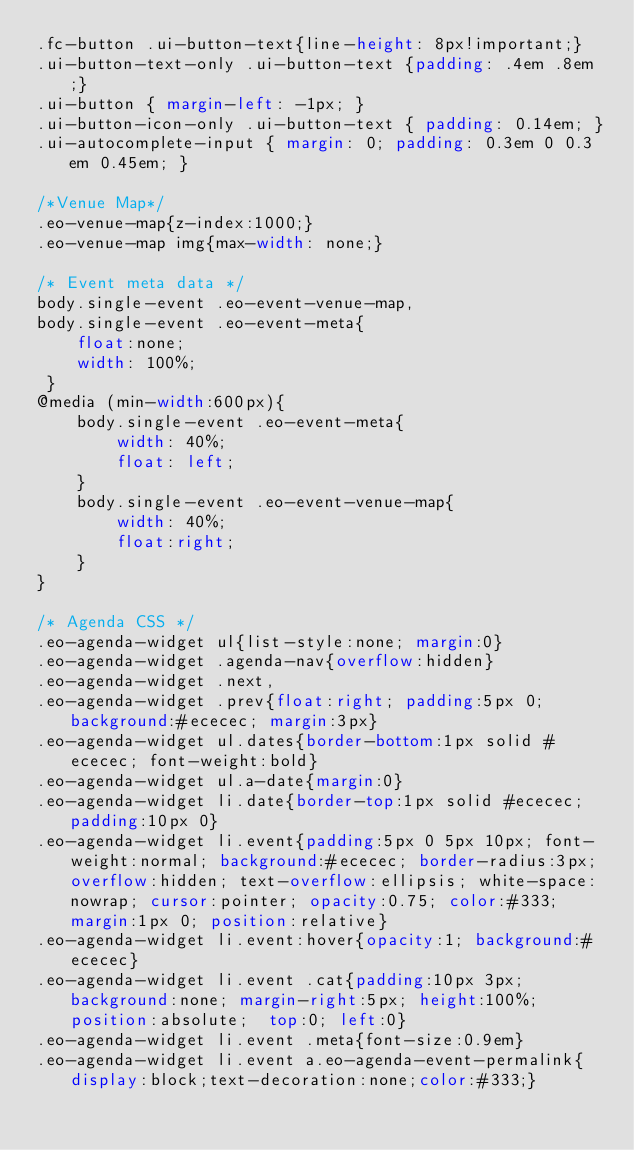Convert code to text. <code><loc_0><loc_0><loc_500><loc_500><_CSS_>.fc-button .ui-button-text{line-height: 8px!important;}
.ui-button-text-only .ui-button-text {padding: .4em .8em;}
.ui-button { margin-left: -1px; }
.ui-button-icon-only .ui-button-text { padding: 0.14em; } 
.ui-autocomplete-input { margin: 0; padding: 0.3em 0 0.3em 0.45em; }

/*Venue Map*/
.eo-venue-map{z-index:1000;}
.eo-venue-map img{max-width: none;}

/* Event meta data */
body.single-event .eo-event-venue-map,
body.single-event .eo-event-meta{
	float:none;
	width: 100%;
 } 
@media (min-width:600px){
	body.single-event .eo-event-meta{
		width: 40%;
		float: left;
	}
	body.single-event .eo-event-venue-map{
		width: 40%;
		float:right;
	}
}

/* Agenda CSS */
.eo-agenda-widget ul{list-style:none; margin:0}
.eo-agenda-widget .agenda-nav{overflow:hidden}
.eo-agenda-widget .next, 
.eo-agenda-widget .prev{float:right; padding:5px 0; background:#ececec; margin:3px}
.eo-agenda-widget ul.dates{border-bottom:1px solid #ececec; font-weight:bold}
.eo-agenda-widget ul.a-date{margin:0}
.eo-agenda-widget li.date{border-top:1px solid #ececec; padding:10px 0}
.eo-agenda-widget li.event{padding:5px 0 5px 10px; font-weight:normal; background:#ececec; border-radius:3px; overflow:hidden; text-overflow:ellipsis; white-space:nowrap; cursor:pointer; opacity:0.75; color:#333; margin:1px 0; position:relative}
.eo-agenda-widget li.event:hover{opacity:1; background:#ececec}
.eo-agenda-widget li.event .cat{padding:10px 3px; background:none; margin-right:5px; height:100%; position:absolute;  top:0; left:0}
.eo-agenda-widget li.event .meta{font-size:0.9em}
.eo-agenda-widget li.event a.eo-agenda-event-permalink{display:block;text-decoration:none;color:#333;}</code> 